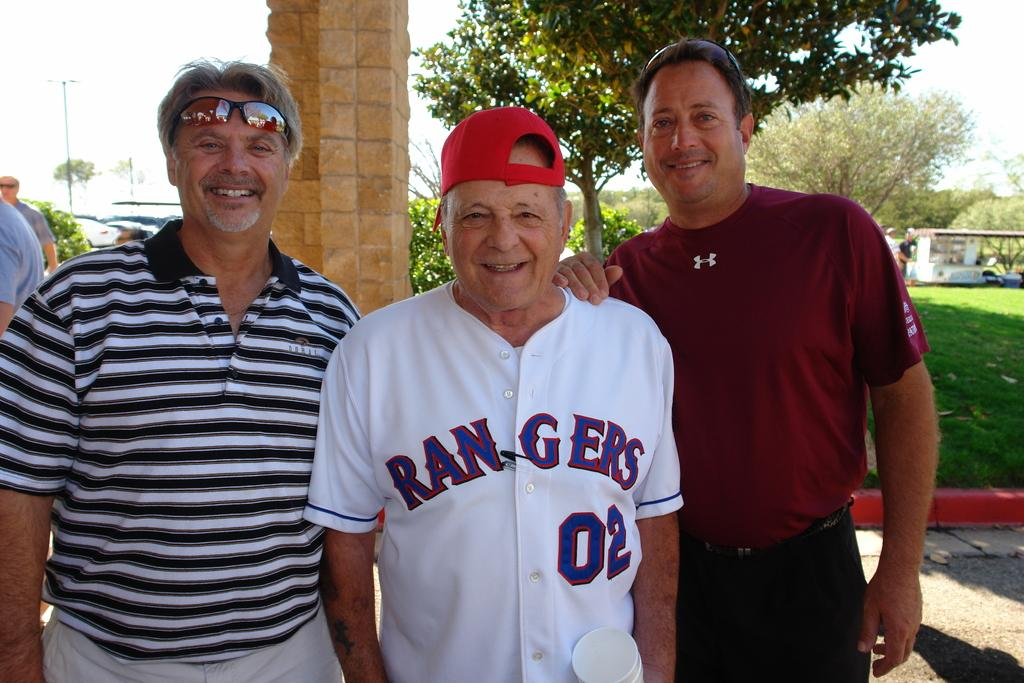<image>
Offer a succinct explanation of the picture presented. Three older men are posing for a picture with the man in the middle wearing a RANGERS shirt. 